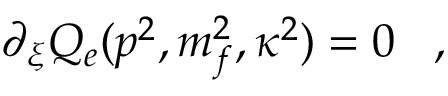Convert formula to latex. <formula><loc_0><loc_0><loc_500><loc_500>\partial _ { \xi } Q _ { e } ( p ^ { 2 } , m _ { f } ^ { 2 } , \kappa ^ { 2 } ) = 0 \, ,</formula> 